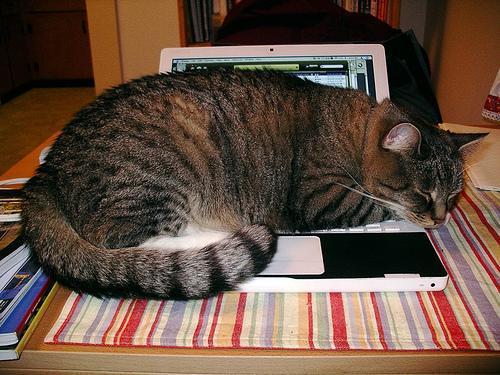How many cats?
Give a very brief answer. 1. How many motorcycles are there in the image?
Give a very brief answer. 0. 